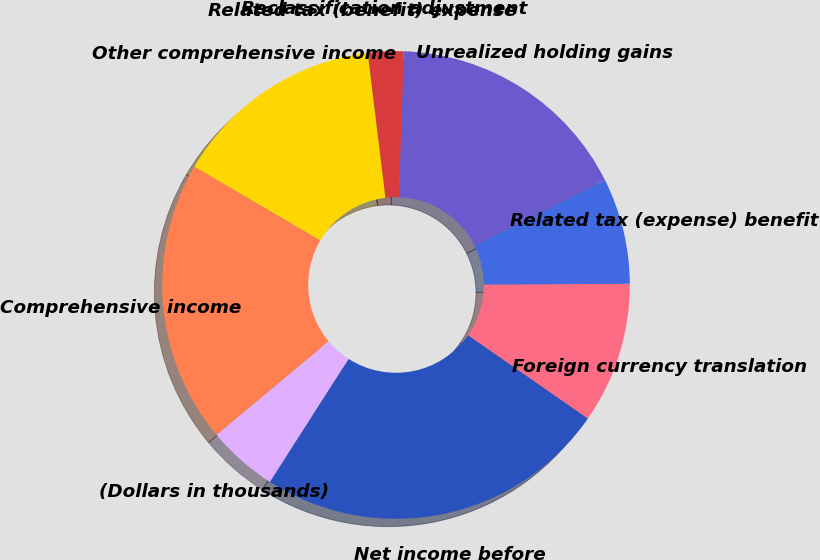<chart> <loc_0><loc_0><loc_500><loc_500><pie_chart><fcel>(Dollars in thousands)<fcel>Net income before<fcel>Foreign currency translation<fcel>Related tax (expense) benefit<fcel>Unrealized holding gains<fcel>Reclassification adjustment<fcel>Related tax (benefit) expense<fcel>Other comprehensive income<fcel>Comprehensive income<nl><fcel>4.88%<fcel>24.38%<fcel>9.76%<fcel>7.32%<fcel>17.07%<fcel>2.45%<fcel>0.01%<fcel>14.63%<fcel>19.5%<nl></chart> 